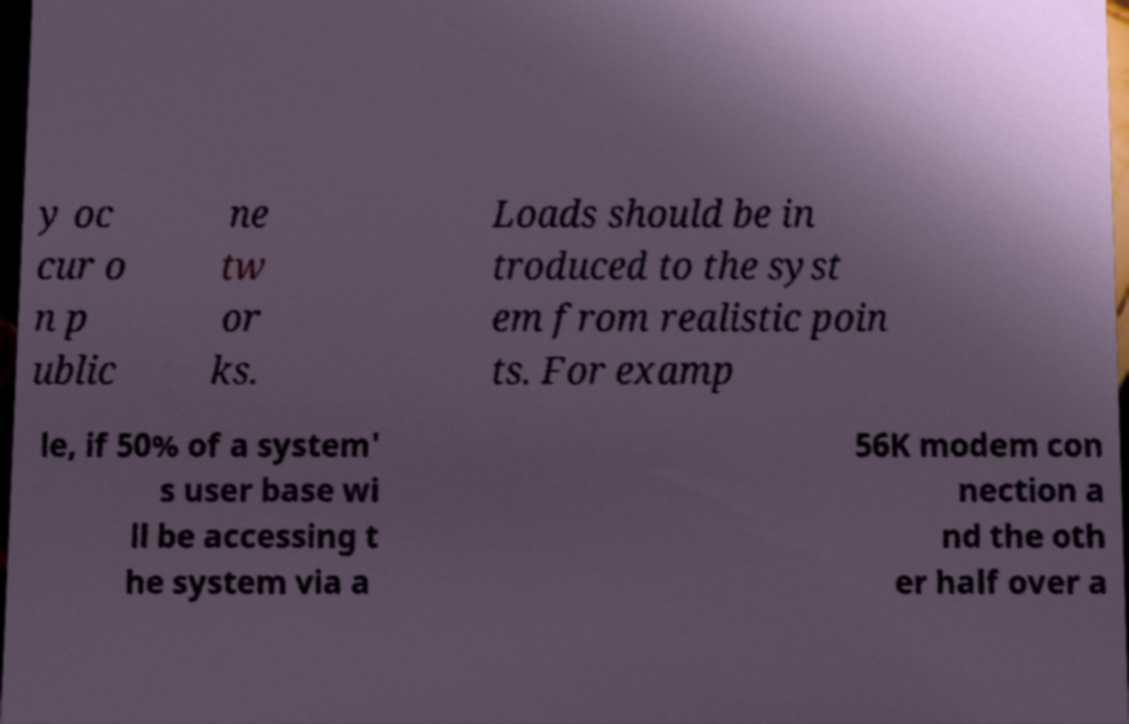What messages or text are displayed in this image? I need them in a readable, typed format. y oc cur o n p ublic ne tw or ks. Loads should be in troduced to the syst em from realistic poin ts. For examp le, if 50% of a system' s user base wi ll be accessing t he system via a 56K modem con nection a nd the oth er half over a 